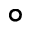<formula> <loc_0><loc_0><loc_500><loc_500>\circ</formula> 